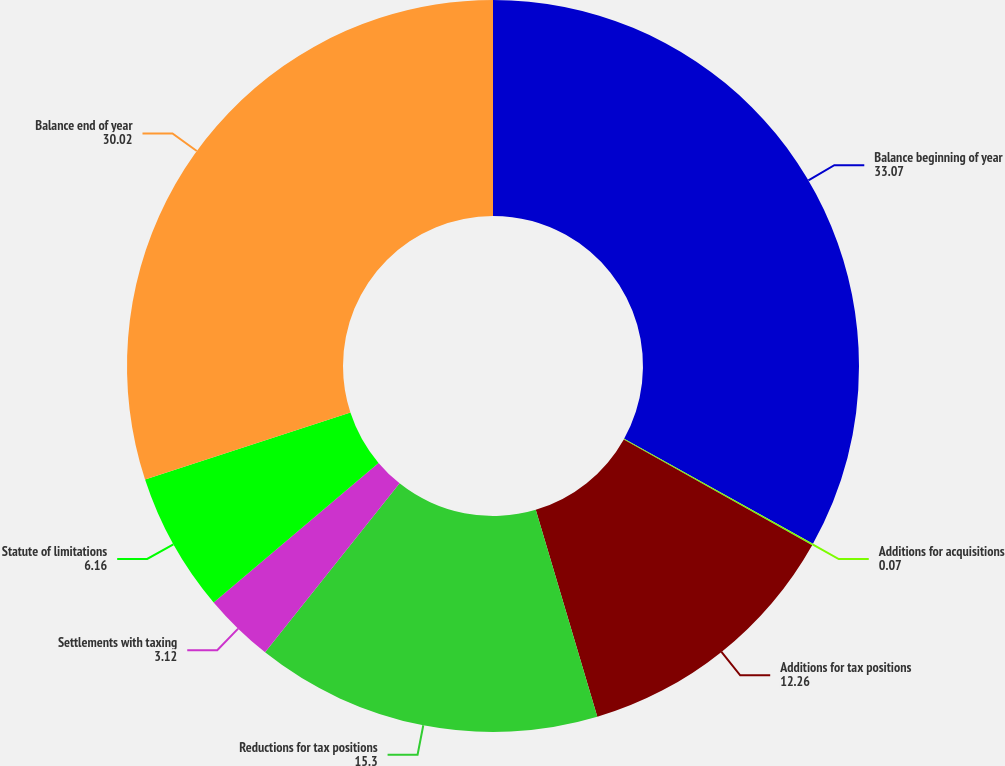Convert chart. <chart><loc_0><loc_0><loc_500><loc_500><pie_chart><fcel>Balance beginning of year<fcel>Additions for acquisitions<fcel>Additions for tax positions<fcel>Reductions for tax positions<fcel>Settlements with taxing<fcel>Statute of limitations<fcel>Balance end of year<nl><fcel>33.07%<fcel>0.07%<fcel>12.26%<fcel>15.3%<fcel>3.12%<fcel>6.16%<fcel>30.02%<nl></chart> 